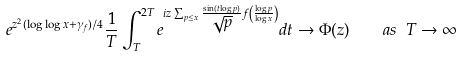<formula> <loc_0><loc_0><loc_500><loc_500>e ^ { z ^ { 2 } ( \log \log x + \gamma _ { f } ) / 4 } \frac { 1 } { T } \int _ { T } ^ { 2 T } e ^ { i z \sum _ { p \leq x } \frac { \sin ( t \log p ) } { \sqrt { p } } f \left ( \frac { \log p } { \log x } \right ) } d t \rightarrow \Phi ( z ) \quad a s \ T \rightarrow \infty</formula> 